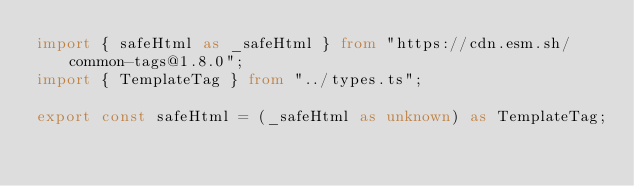Convert code to text. <code><loc_0><loc_0><loc_500><loc_500><_TypeScript_>import { safeHtml as _safeHtml } from "https://cdn.esm.sh/common-tags@1.8.0";
import { TemplateTag } from "../types.ts";

export const safeHtml = (_safeHtml as unknown) as TemplateTag;
</code> 